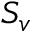<formula> <loc_0><loc_0><loc_500><loc_500>S _ { v }</formula> 